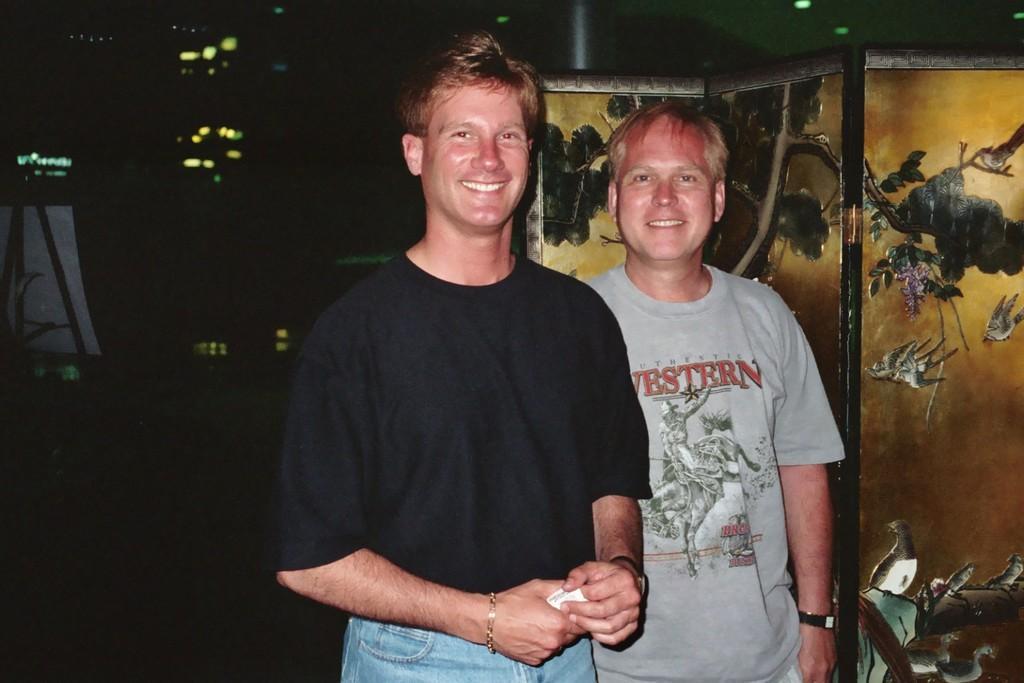Could you give a brief overview of what you see in this image? In this image in the center there are two persons who are standing and smiling and beside them there is one board, on the board there is some art and in the background there are some lights. 